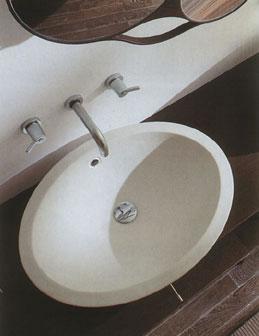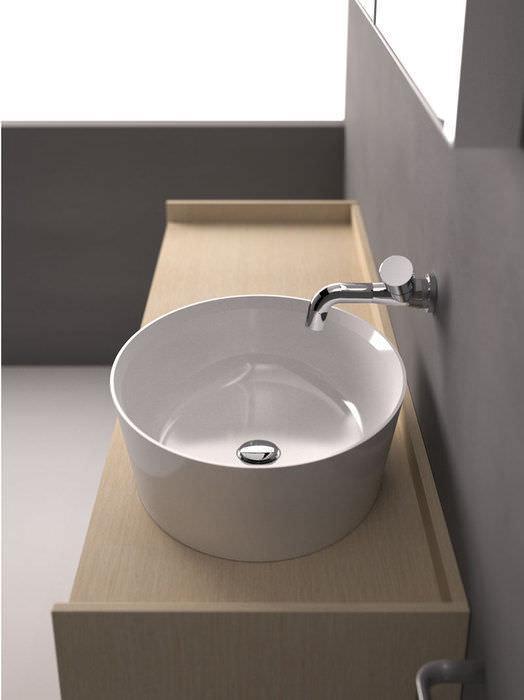The first image is the image on the left, the second image is the image on the right. For the images displayed, is the sentence "Each sink is rounded, white, sits atop a counter, and has the spout and faucet mounted on the wall above it." factually correct? Answer yes or no. Yes. The first image is the image on the left, the second image is the image on the right. For the images displayed, is the sentence "One white sink is round and one is oval, neither directly attached to a chrome spout fixture that overhangs it." factually correct? Answer yes or no. Yes. 